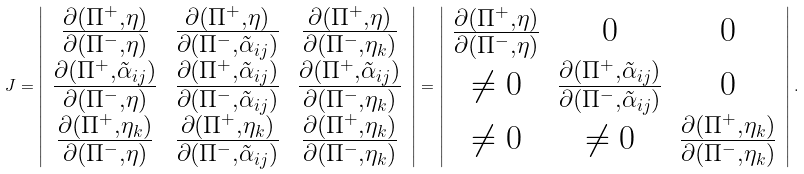Convert formula to latex. <formula><loc_0><loc_0><loc_500><loc_500>J = \left | \begin{array} { c c c } \frac { \partial ( \Pi ^ { + } , \eta ) } { \partial ( \Pi ^ { - } , \eta ) } & \frac { \partial ( \Pi ^ { + } , \eta ) } { \partial ( \Pi ^ { - } , \tilde { \alpha } _ { i j } ) } & \frac { \partial ( \Pi ^ { + } , \eta ) } { \partial ( \Pi ^ { - } , \eta _ { k } ) } \\ \frac { \partial ( \Pi ^ { + } , \tilde { \alpha } _ { i j } ) } { \partial ( \Pi ^ { - } , \eta ) } & \frac { \partial ( \Pi ^ { + } , \tilde { \alpha } _ { i j } ) } { \partial ( \Pi ^ { - } , \tilde { \alpha } _ { i j } ) } & \frac { \partial ( \Pi ^ { + } , \tilde { \alpha } _ { i j } ) } { \partial ( \Pi ^ { - } , \eta _ { k } ) } \\ \frac { \partial ( \Pi ^ { + } , \eta _ { k } ) } { \partial ( \Pi ^ { - } , \eta ) } & \frac { \partial ( \Pi ^ { + } , \eta _ { k } ) } { \partial ( \Pi ^ { - } , \tilde { \alpha } _ { i j } ) } & \frac { \partial ( \Pi ^ { + } , \eta _ { k } ) } { \partial ( \Pi ^ { - } , \eta _ { k } ) } \end{array} \right | = \left | \begin{array} { c c c } \frac { \partial ( \Pi ^ { + } , \eta ) } { \partial ( \Pi ^ { - } , \eta ) } & 0 & 0 \\ \neq 0 & \frac { \partial ( \Pi ^ { + } , \tilde { \alpha } _ { i j } ) } { \partial ( \Pi ^ { - } , \tilde { \alpha } _ { i j } ) } & 0 \\ \neq 0 & \neq 0 & \frac { \partial ( \Pi ^ { + } , \eta _ { k } ) } { \partial ( \Pi ^ { - } , \eta _ { k } ) } \end{array} \right | .</formula> 